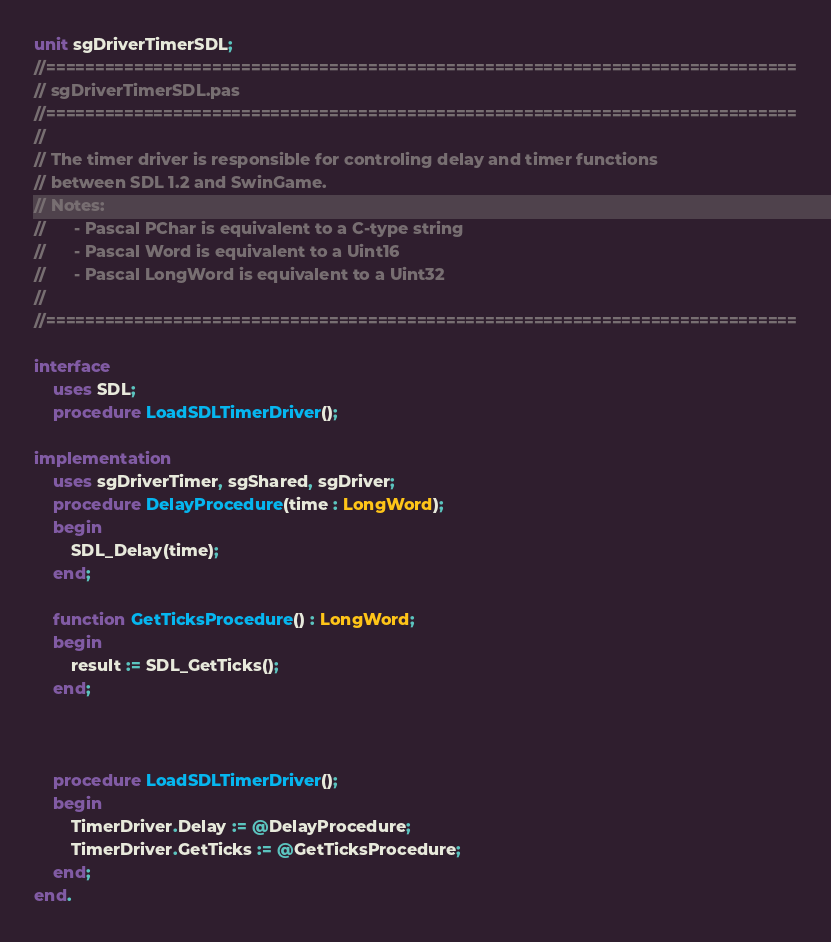<code> <loc_0><loc_0><loc_500><loc_500><_Pascal_>unit sgDriverTimerSDL;
//=============================================================================
// sgDriverTimerSDL.pas
//=============================================================================
//
// The timer driver is responsible for controling delay and timer functions 
// between SDL 1.2 and SwinGame.
// Notes:
//		- Pascal PChar is equivalent to a C-type string
// 		- Pascal Word is equivalent to a Uint16
//		- Pascal LongWord is equivalent to a Uint32
//
//=============================================================================

interface 
	uses SDL;
	procedure LoadSDLTimerDriver();
	
implementation
	uses sgDriverTimer, sgShared, sgDriver;
	procedure DelayProcedure(time : LongWord);
	begin
		SDL_Delay(time);
	end;
	
	function GetTicksProcedure() : LongWord;
	begin
		result := SDL_GetTicks();
	end;
	

	
	procedure LoadSDLTimerDriver();
	begin
		TimerDriver.Delay := @DelayProcedure;
		TimerDriver.GetTicks := @GetTicksProcedure;
	end;
end.</code> 